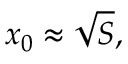<formula> <loc_0><loc_0><loc_500><loc_500>x _ { 0 } \approx { \sqrt { S } } ,</formula> 